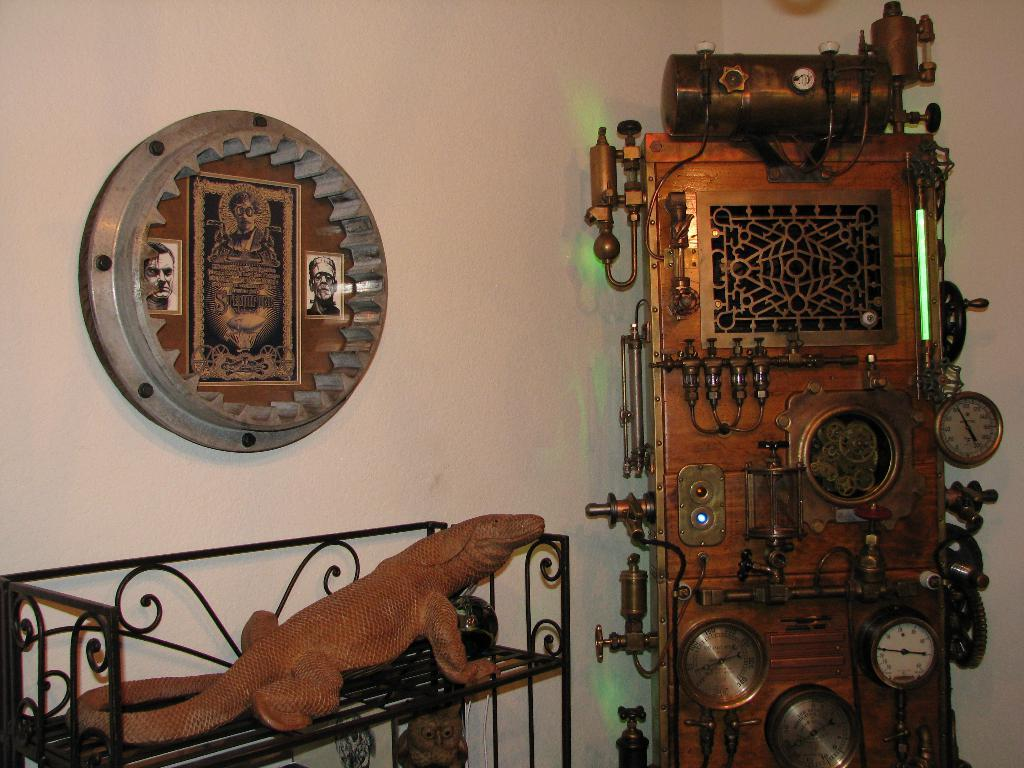What is the main object in the image? There is a control panel in the image. What is located beside the control panel? There is a rack beside the control panel. What is depicted on the rack? There is a depiction of a crocodile on the rack. What can be seen hanging on the wall in the image? There is a frame hanging on the wall in the image. What type of loaf is being used to grade the station in the image? There is no loaf or station present in the image. 